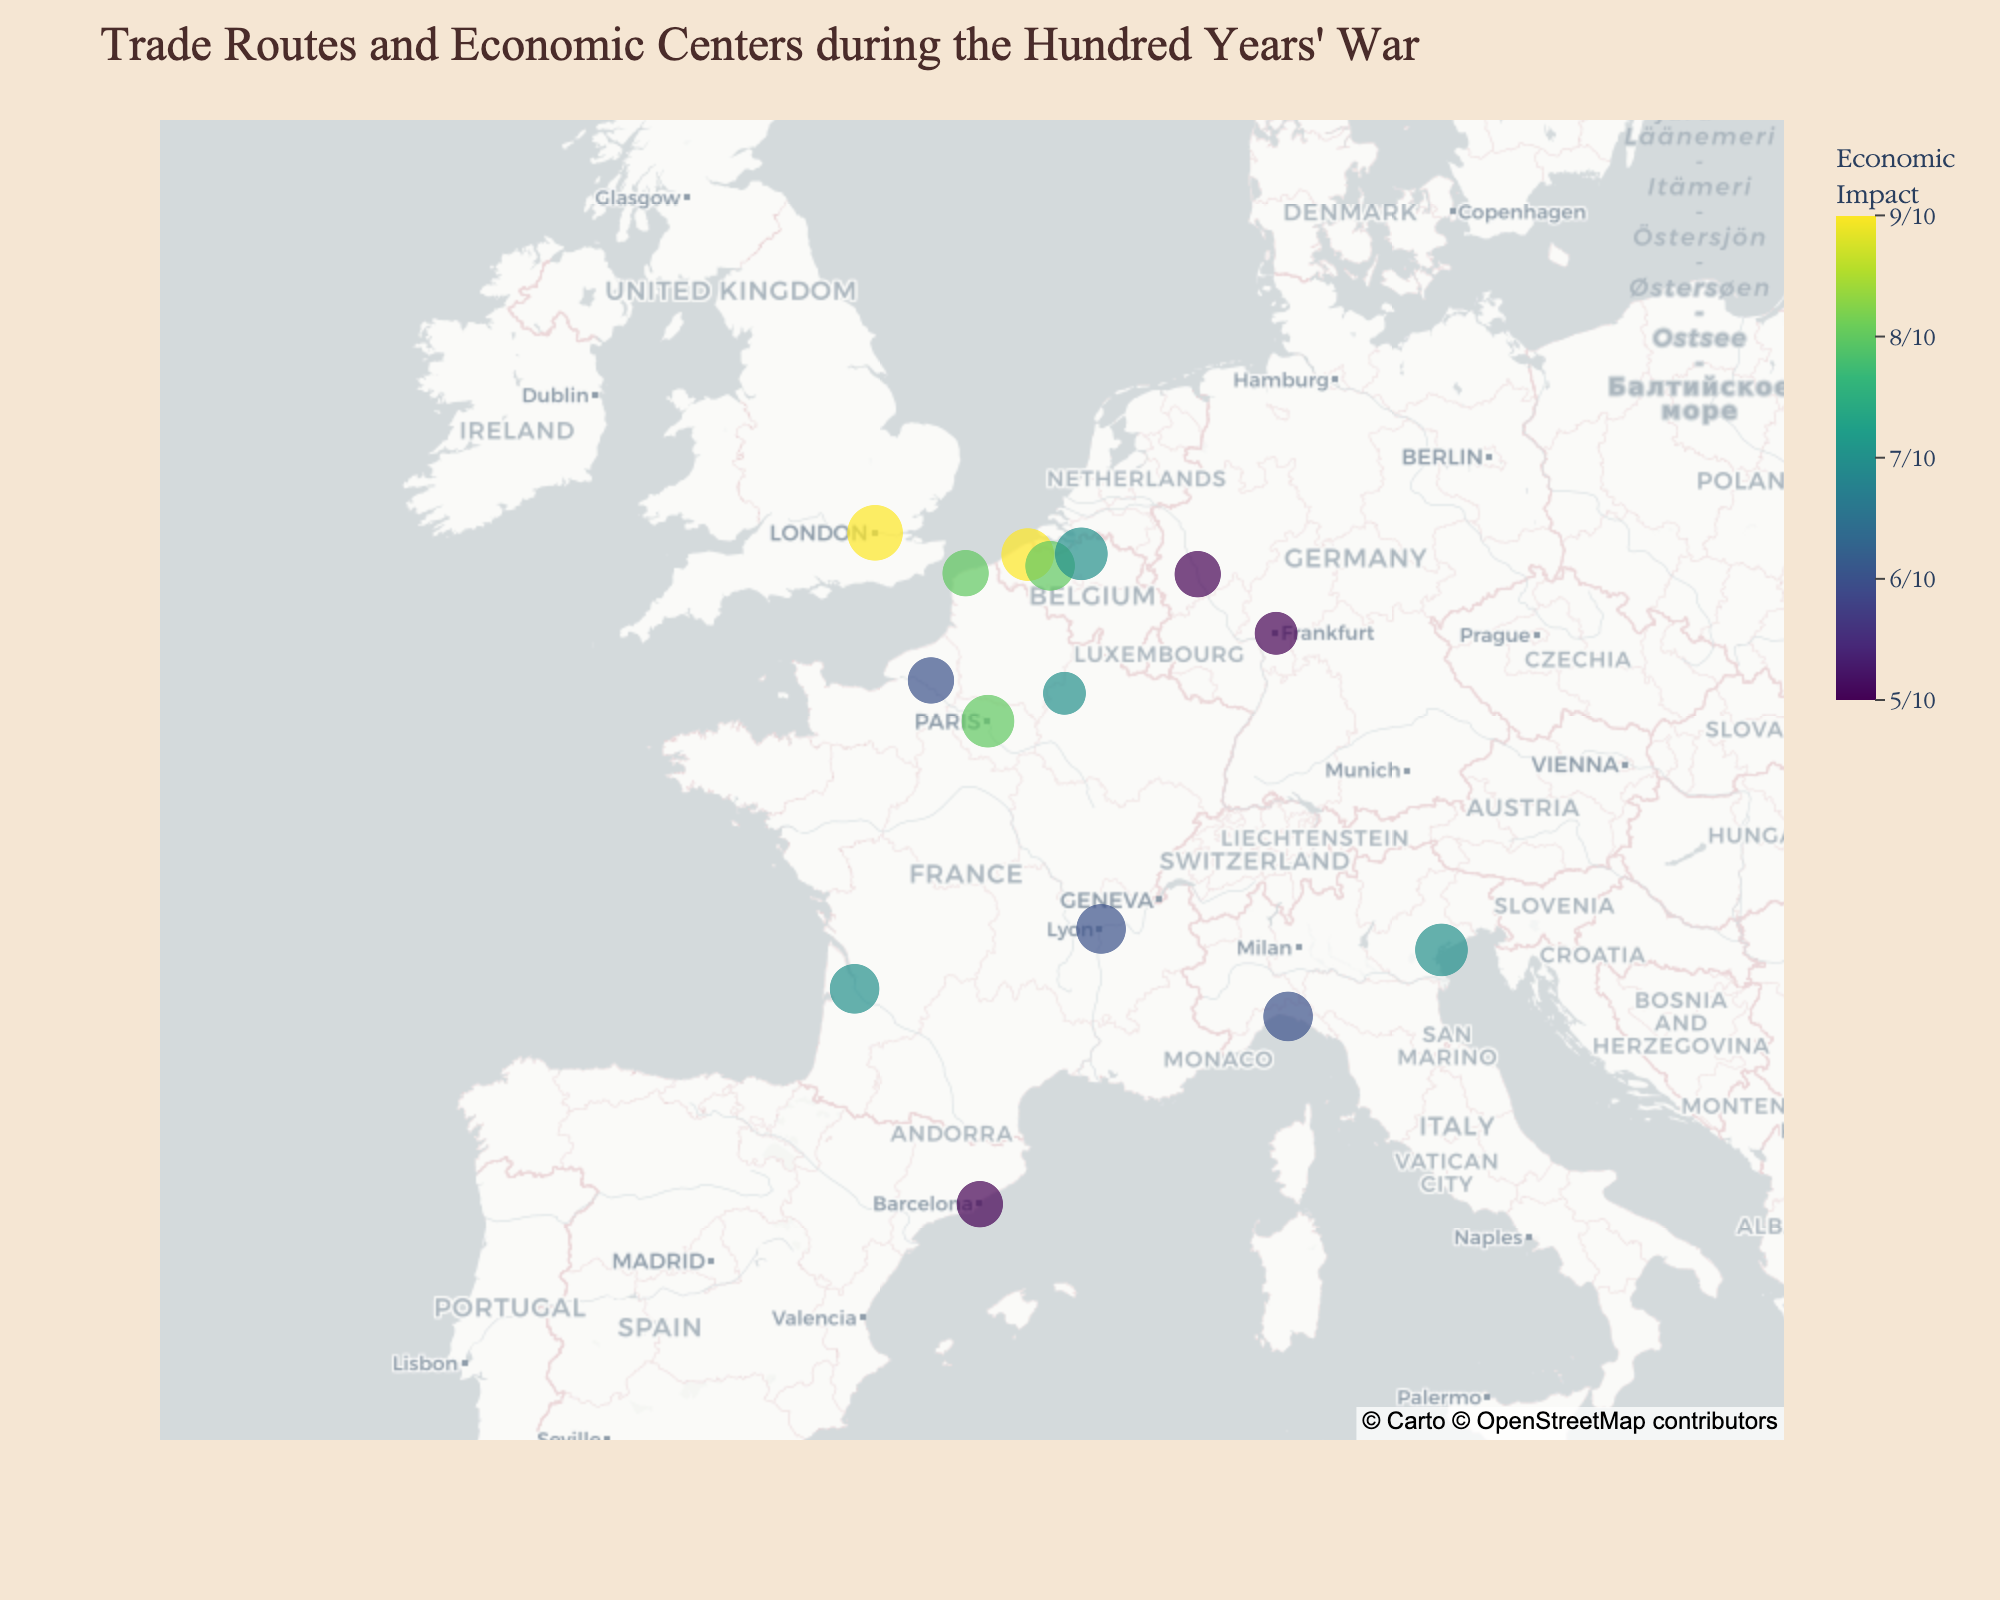Which city is marked with the highest trade importance? The Trade_Importance is represented by the size of the markers on the map. The largest marker corresponds to London with a Trade_Importance of 10.
Answer: London Which country has the most cities shown in the map? By counting the number of cities per country: France has Paris, Bordeaux, Calais, Rouen, and Reims (5 cities). This is the highest number.
Answer: France Is Paris shown to have a higher or lower economic impact than Bordeaux? By comparing the Economic_Impact values (shown by color intensity), Paris has an Economic_Impact of 8, while Bordeaux has 7. Thus, Paris has a higher impact.
Answer: Higher How many cities have a trade importance of 9? By counting the cities with Trade_Importance = 9: London, Paris, Bruges, Venice, and Antwerp. This totals to 5 cities.
Answer: 5 What is the title of the map? The title is clearly stated at the top of the map. It reads: "Trade Routes and Economic Centers during the Hundred Years' War."
Answer: Trade Routes and Economic Centers during the Hundred Years' War Compare the economic impact of cities in Belgium; which one has the highest value? By comparing the Economic_Impact of cities in Belgium: Bruges (9), Ghent (8), Antwerp (7). So, Bruges has the highest value.
Answer: Bruges Which city in France has the least economic impact according to the map? By checking the French cities: Paris (8), Bordeaux (7), Calais (8), Rouen (6), Reims (7). Rouen has the least economic impact.
Answer: Rouen What's the average trade importance of all the cities shown on the map? By calculating the average: (10+9+8+7+9+8+9+7+6+8+7+6+8+9+7)/15 = 7.87.
Answer: 7.87 Name a city in Germany shown on the map and its trade importance. By identifying the German cities: Cologne and Frankfurt. Cologne has a Trade_Importance of 7, and Frankfurt has 6. For example, Cologne.
Answer: Cologne, 7 